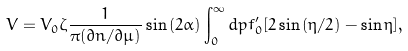Convert formula to latex. <formula><loc_0><loc_0><loc_500><loc_500>V = V _ { 0 } \zeta \frac { 1 } { \pi ( \partial n / \partial \mu ) } \sin { ( 2 \alpha ) } \int _ { 0 } ^ { \infty } d p f _ { 0 } ^ { \prime } [ 2 \sin { ( \eta / 2 ) } - \sin { \eta } ] ,</formula> 